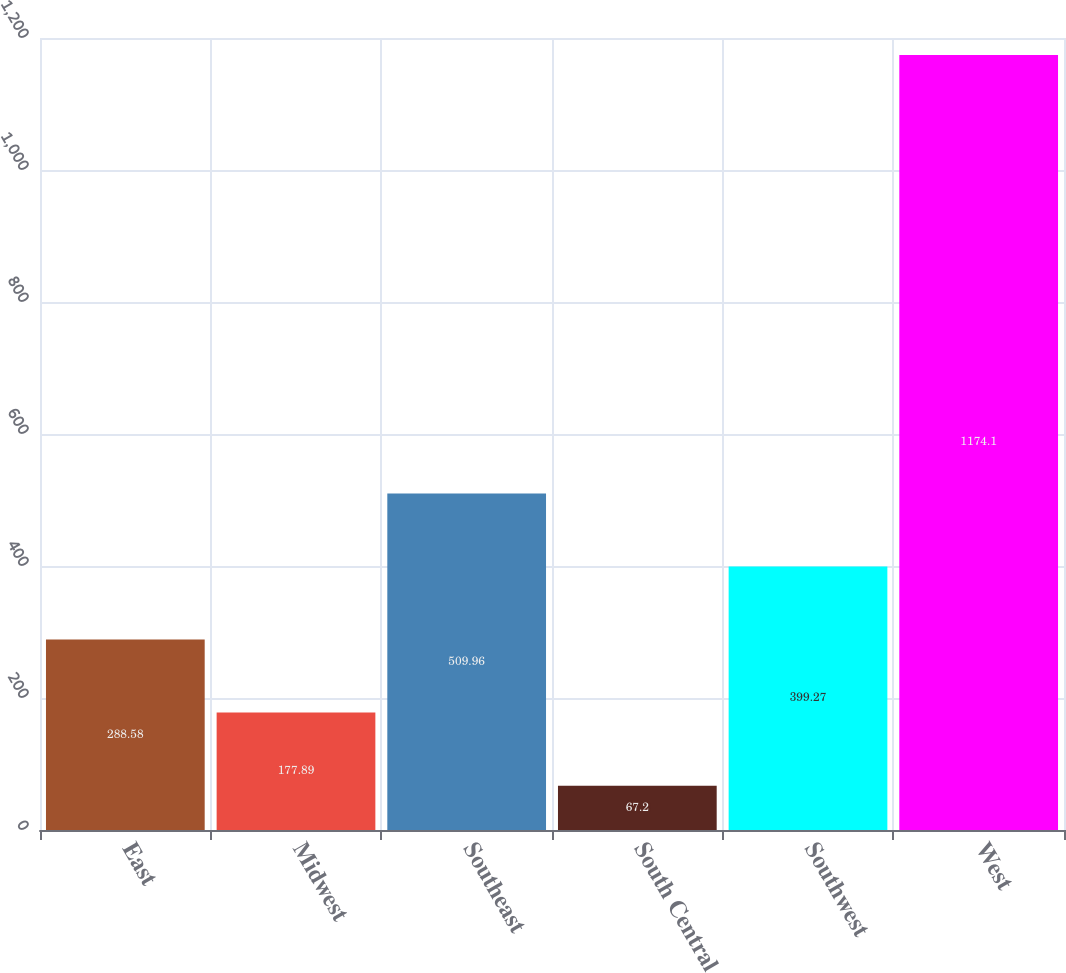Convert chart. <chart><loc_0><loc_0><loc_500><loc_500><bar_chart><fcel>East<fcel>Midwest<fcel>Southeast<fcel>South Central<fcel>Southwest<fcel>West<nl><fcel>288.58<fcel>177.89<fcel>509.96<fcel>67.2<fcel>399.27<fcel>1174.1<nl></chart> 